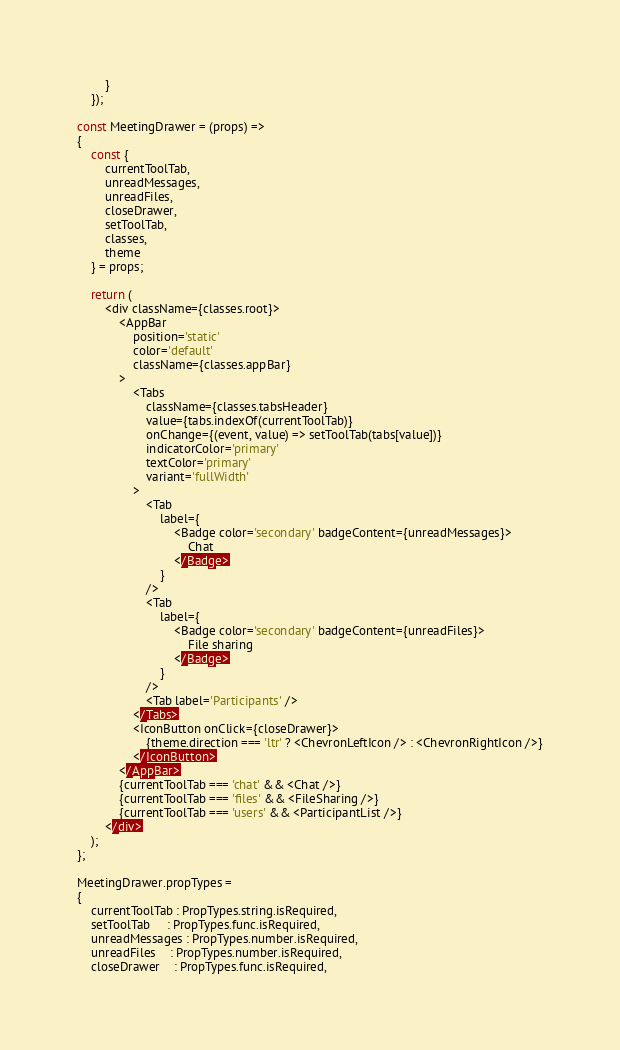Convert code to text. <code><loc_0><loc_0><loc_500><loc_500><_JavaScript_>		}
	});

const MeetingDrawer = (props) =>
{
	const {
		currentToolTab,
		unreadMessages,
		unreadFiles,
		closeDrawer,
		setToolTab,
		classes,
		theme
	} = props;

	return (
		<div className={classes.root}>
			<AppBar
				position='static'
				color='default'
				className={classes.appBar}
			>
				<Tabs
					className={classes.tabsHeader}
					value={tabs.indexOf(currentToolTab)}
					onChange={(event, value) => setToolTab(tabs[value])}
					indicatorColor='primary'
					textColor='primary'
					variant='fullWidth'
				>
					<Tab
						label={
							<Badge color='secondary' badgeContent={unreadMessages}>
								Chat
							</Badge>
						}
					/>
					<Tab
						label={
							<Badge color='secondary' badgeContent={unreadFiles}>
								File sharing
							</Badge>
						}
					/>
					<Tab label='Participants' />
				</Tabs>
				<IconButton onClick={closeDrawer}>
					{theme.direction === 'ltr' ? <ChevronLeftIcon /> : <ChevronRightIcon />}
				</IconButton>
			</AppBar>
			{currentToolTab === 'chat' && <Chat />}
			{currentToolTab === 'files' && <FileSharing />}
			{currentToolTab === 'users' && <ParticipantList />}
		</div>
	);
};

MeetingDrawer.propTypes =
{
	currentToolTab : PropTypes.string.isRequired,
	setToolTab     : PropTypes.func.isRequired,
	unreadMessages : PropTypes.number.isRequired,
	unreadFiles    : PropTypes.number.isRequired,
	closeDrawer    : PropTypes.func.isRequired,</code> 